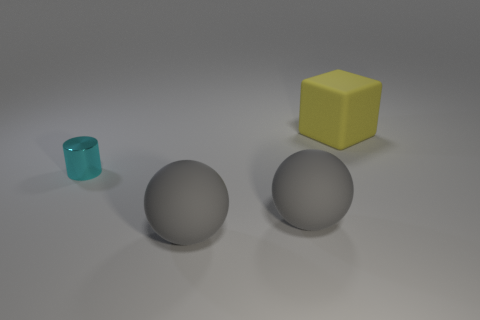Add 3 large gray matte balls. How many objects exist? 7 Subtract all blocks. How many objects are left? 3 Add 2 gray objects. How many gray objects are left? 4 Add 2 yellow objects. How many yellow objects exist? 3 Subtract 0 blue cylinders. How many objects are left? 4 Subtract all small purple metallic balls. Subtract all gray objects. How many objects are left? 2 